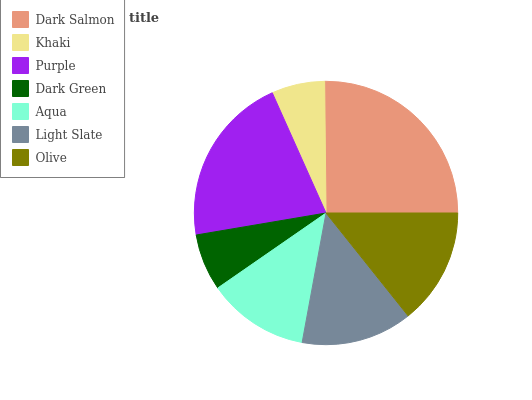Is Khaki the minimum?
Answer yes or no. Yes. Is Dark Salmon the maximum?
Answer yes or no. Yes. Is Purple the minimum?
Answer yes or no. No. Is Purple the maximum?
Answer yes or no. No. Is Purple greater than Khaki?
Answer yes or no. Yes. Is Khaki less than Purple?
Answer yes or no. Yes. Is Khaki greater than Purple?
Answer yes or no. No. Is Purple less than Khaki?
Answer yes or no. No. Is Light Slate the high median?
Answer yes or no. Yes. Is Light Slate the low median?
Answer yes or no. Yes. Is Dark Salmon the high median?
Answer yes or no. No. Is Khaki the low median?
Answer yes or no. No. 